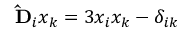<formula> <loc_0><loc_0><loc_500><loc_500>\hat { D } _ { i } x _ { k } = 3 x _ { i } x _ { k } - \delta _ { i k }</formula> 